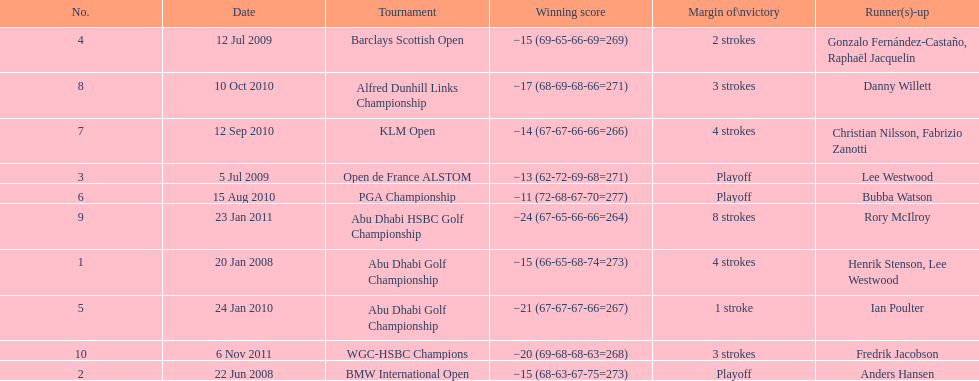What are all of the tournaments? Abu Dhabi Golf Championship, BMW International Open, Open de France ALSTOM, Barclays Scottish Open, Abu Dhabi Golf Championship, PGA Championship, KLM Open, Alfred Dunhill Links Championship, Abu Dhabi HSBC Golf Championship, WGC-HSBC Champions. What was the score during each? −15 (66-65-68-74=273), −15 (68-63-67-75=273), −13 (62-72-69-68=271), −15 (69-65-66-69=269), −21 (67-67-67-66=267), −11 (72-68-67-70=277), −14 (67-67-66-66=266), −17 (68-69-68-66=271), −24 (67-65-66-66=264), −20 (69-68-68-63=268). Would you mind parsing the complete table? {'header': ['No.', 'Date', 'Tournament', 'Winning score', 'Margin of\\nvictory', 'Runner(s)-up'], 'rows': [['4', '12 Jul 2009', 'Barclays Scottish Open', '−15 (69-65-66-69=269)', '2 strokes', 'Gonzalo Fernández-Castaño, Raphaël Jacquelin'], ['8', '10 Oct 2010', 'Alfred Dunhill Links Championship', '−17 (68-69-68-66=271)', '3 strokes', 'Danny Willett'], ['7', '12 Sep 2010', 'KLM Open', '−14 (67-67-66-66=266)', '4 strokes', 'Christian Nilsson, Fabrizio Zanotti'], ['3', '5 Jul 2009', 'Open de France ALSTOM', '−13 (62-72-69-68=271)', 'Playoff', 'Lee Westwood'], ['6', '15 Aug 2010', 'PGA Championship', '−11 (72-68-67-70=277)', 'Playoff', 'Bubba Watson'], ['9', '23 Jan 2011', 'Abu Dhabi HSBC Golf Championship', '−24 (67-65-66-66=264)', '8 strokes', 'Rory McIlroy'], ['1', '20 Jan 2008', 'Abu Dhabi Golf Championship', '−15 (66-65-68-74=273)', '4 strokes', 'Henrik Stenson, Lee Westwood'], ['5', '24 Jan 2010', 'Abu Dhabi Golf Championship', '−21 (67-67-67-66=267)', '1 stroke', 'Ian Poulter'], ['10', '6 Nov 2011', 'WGC-HSBC Champions', '−20 (69-68-68-63=268)', '3 strokes', 'Fredrik Jacobson'], ['2', '22 Jun 2008', 'BMW International Open', '−15 (68-63-67-75=273)', 'Playoff', 'Anders Hansen']]} And who was the runner-up in each? Henrik Stenson, Lee Westwood, Anders Hansen, Lee Westwood, Gonzalo Fernández-Castaño, Raphaël Jacquelin, Ian Poulter, Bubba Watson, Christian Nilsson, Fabrizio Zanotti, Danny Willett, Rory McIlroy, Fredrik Jacobson. What about just during pga games? Bubba Watson. 